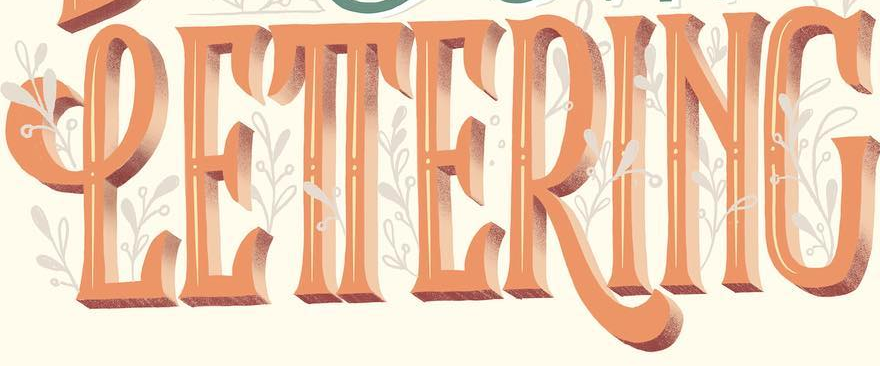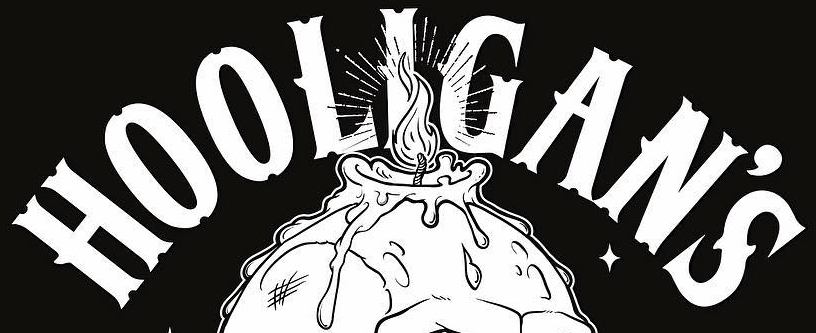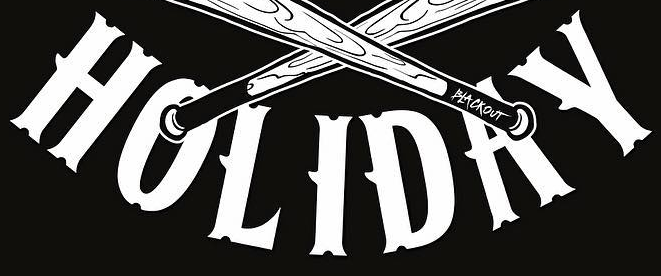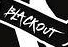What text is displayed in these images sequentially, separated by a semicolon? LETTERING; HOOLIGAN'S; HOLIDAY; BLACKOUT 